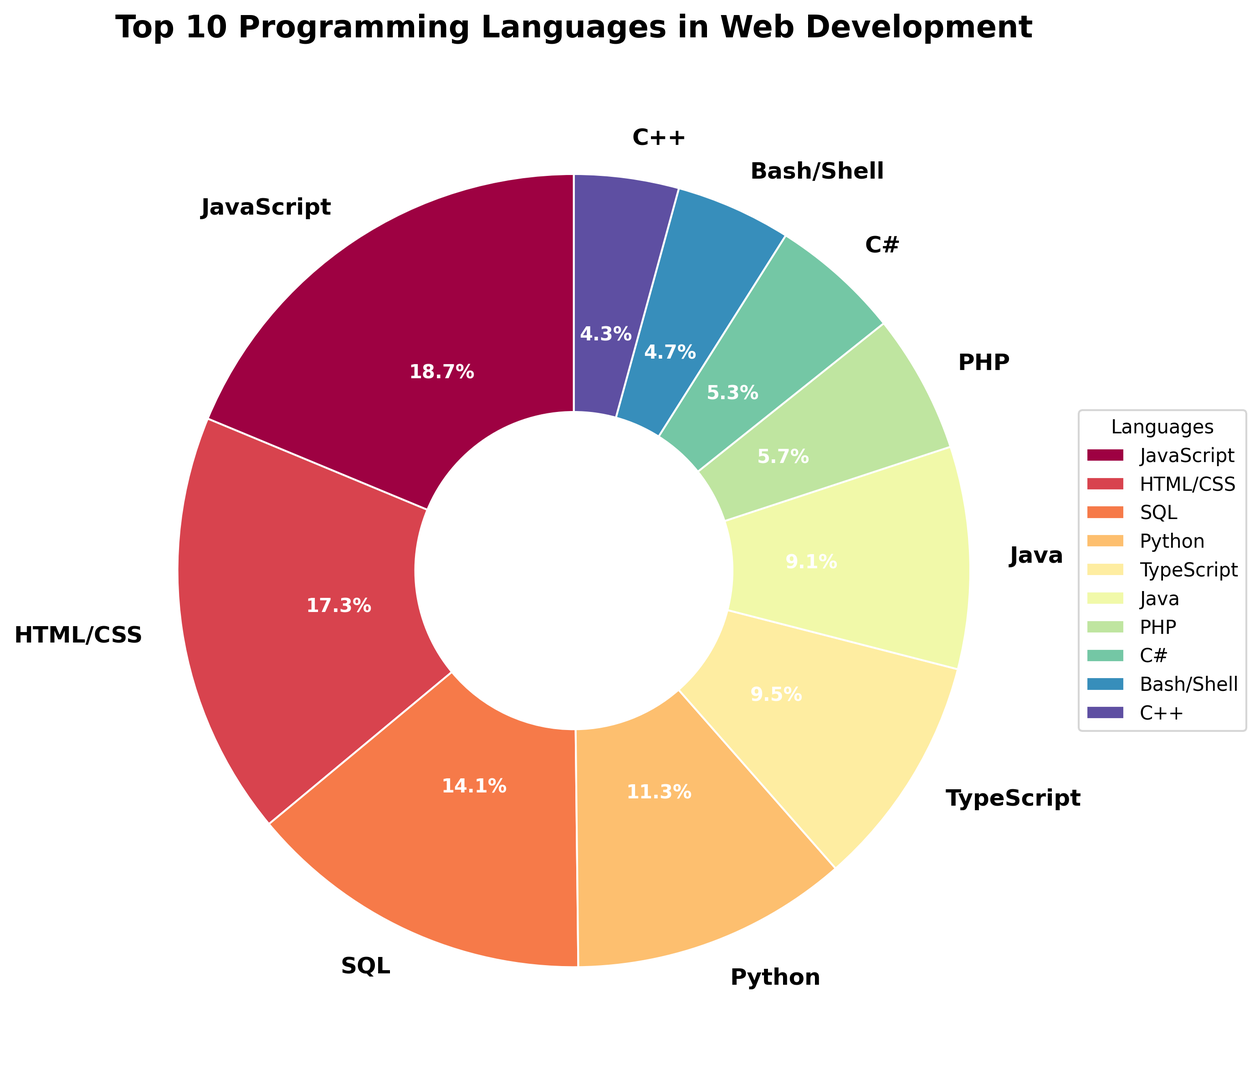Which programming language has the largest share in web development? To find the answer, look at the pie chart segments and identify the one with the largest percentage. The segment representing JavaScript is the largest with 68.5%.
Answer: JavaScript How much larger is the share of JavaScript compared to Python? First, note the percentages of JavaScript (68.5%) and Python (41.3%). Subtract Python's percentage from JavaScript's percentage: 68.5% - 41.3% = 27.2%.
Answer: 27.2% Which language has a higher usage, PHP or C#? Compare the percentages for PHP (20.7%) and C# (19.4%). PHP has a higher percentage.
Answer: PHP What is the combined percentage of the top 3 languages? Add the percentages of the top 3 languages: JavaScript (68.5%), HTML/CSS (63.2%), and SQL (51.7%). The combined percentage is 68.5 + 63.2 + 51.7 = 183.4%.
Answer: 183.4% What is the difference in usage percentage between TypeScript and Java? Note TypeScript's percentage (34.8%) and Java's percentage (33.1%). The difference is 34.8% - 33.1% = 1.7%.
Answer: 1.7% Which color represents Python in the pie chart? Identify the color used for the Python segment by matching the label "Python (41.3%)" to its corresponding color in the chart.
Answer: Dark orange (the exact shade naming is visual) How many languages have a usage percentage of less than 20%? Identify the segments with less than 20% in the top 10 list. PHP (20.7%) is not included, but C# (19.4%) and C++ (15.6%) are. So there are 2 such languages.
Answer: 2 Rank the top 5 languages from most to least common. Refer to the percentages given in the pie chart labels for the top 5 segments: JavaScript (68.5%), HTML/CSS (63.2%), SQL (51.7%), Python (41.3%), and TypeScript (34.8%).
Answer: JavaScript, HTML/CSS, SQL, Python, TypeScript What percentage of the top 10 languages is covered by Java, PHP, and C# together? Add the percentages of Java (33.1%), PHP (20.7%), and C# (19.4%). The combined percentage is 33.1 + 20.7 + 19.4 = 73.2%.
Answer: 73.2% 